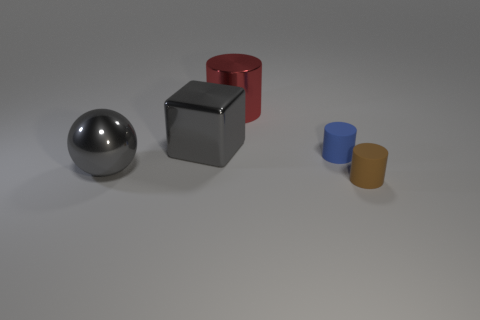There is a matte thing that is on the left side of the matte object in front of the large gray shiny sphere; how big is it?
Provide a succinct answer. Small. Does the gray metallic object that is behind the sphere have the same size as the small blue matte object?
Make the answer very short. No. Are there any metal objects that have the same color as the block?
Make the answer very short. Yes. Is the block the same color as the large shiny cylinder?
Provide a short and direct response. No. There is a object that is on the left side of the brown matte thing and in front of the blue matte cylinder; what is its size?
Offer a very short reply. Large. What color is the big cylinder that is the same material as the large gray block?
Keep it short and to the point. Red. Is the shape of the brown matte object the same as the big metal thing in front of the big gray metal block?
Keep it short and to the point. No. Are the big red object and the tiny blue object that is right of the shiny block made of the same material?
Provide a short and direct response. No. What color is the large thing behind the gray object that is to the right of the gray object that is left of the big block?
Offer a terse response. Red. Is the color of the metallic sphere the same as the block that is left of the small blue matte cylinder?
Your response must be concise. Yes. 